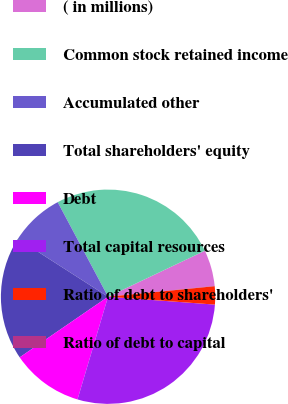Convert chart. <chart><loc_0><loc_0><loc_500><loc_500><pie_chart><fcel>( in millions)<fcel>Common stock retained income<fcel>Accumulated other<fcel>Total shareholders' equity<fcel>Debt<fcel>Total capital resources<fcel>Ratio of debt to shareholders'<fcel>Ratio of debt to capital<nl><fcel>5.44%<fcel>25.73%<fcel>8.13%<fcel>18.65%<fcel>10.83%<fcel>28.43%<fcel>2.74%<fcel>0.05%<nl></chart> 